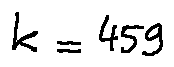<formula> <loc_0><loc_0><loc_500><loc_500>k = 4 5 9</formula> 